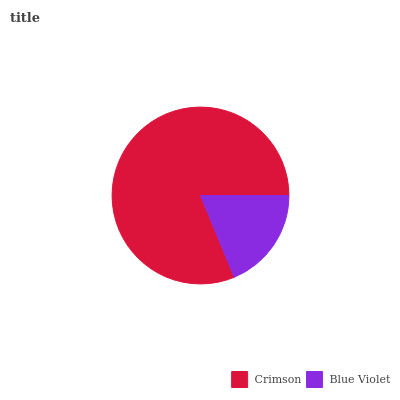Is Blue Violet the minimum?
Answer yes or no. Yes. Is Crimson the maximum?
Answer yes or no. Yes. Is Blue Violet the maximum?
Answer yes or no. No. Is Crimson greater than Blue Violet?
Answer yes or no. Yes. Is Blue Violet less than Crimson?
Answer yes or no. Yes. Is Blue Violet greater than Crimson?
Answer yes or no. No. Is Crimson less than Blue Violet?
Answer yes or no. No. Is Crimson the high median?
Answer yes or no. Yes. Is Blue Violet the low median?
Answer yes or no. Yes. Is Blue Violet the high median?
Answer yes or no. No. Is Crimson the low median?
Answer yes or no. No. 